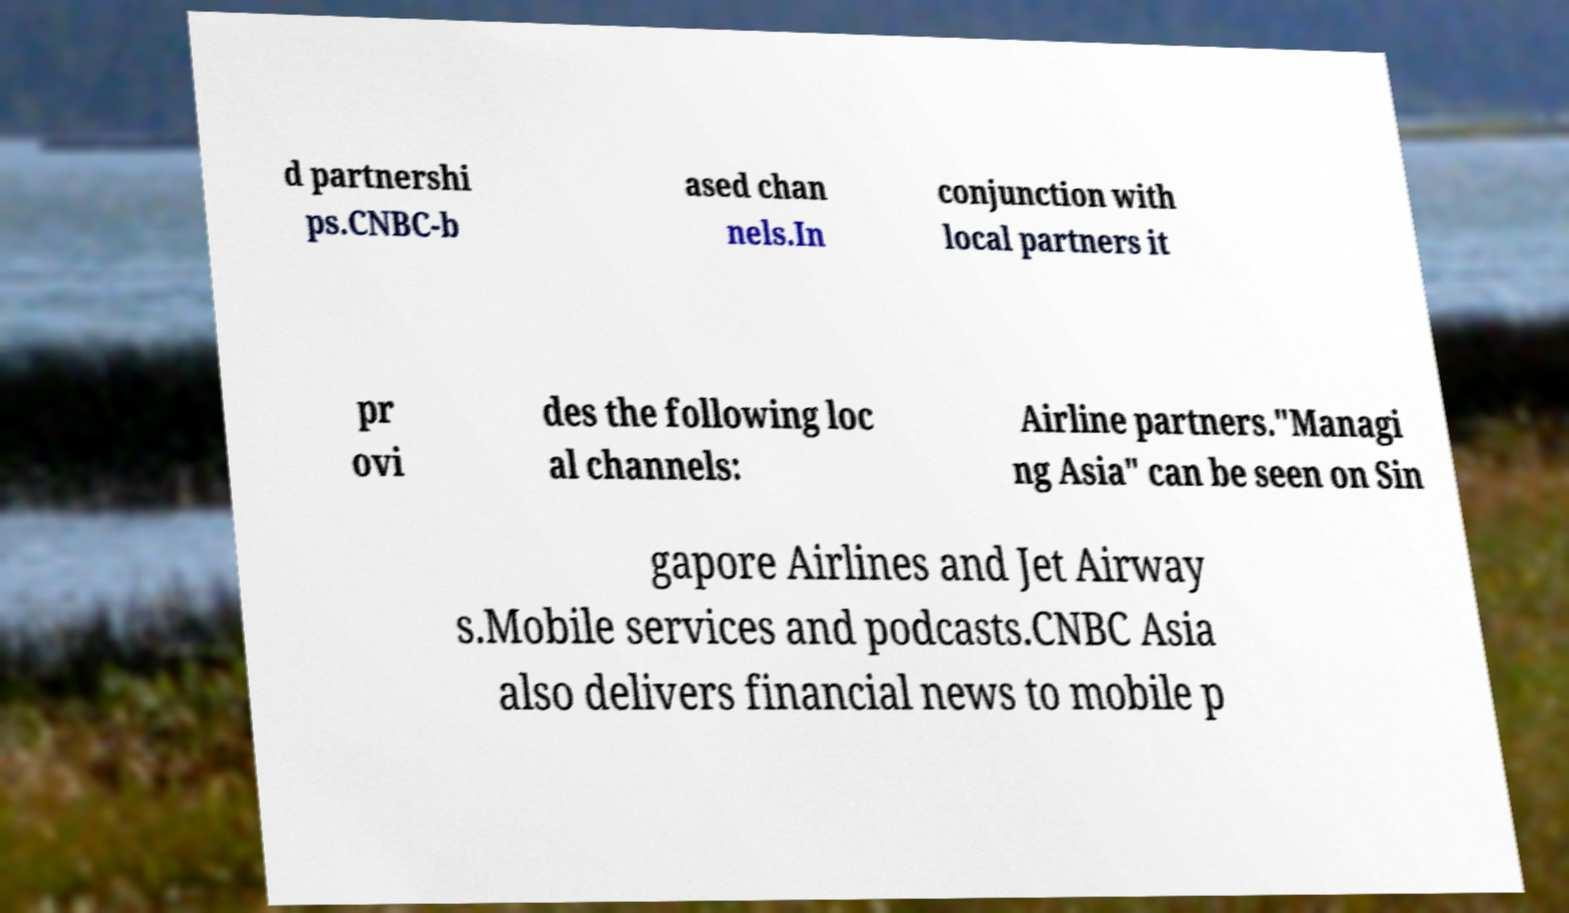Could you assist in decoding the text presented in this image and type it out clearly? d partnershi ps.CNBC-b ased chan nels.In conjunction with local partners it pr ovi des the following loc al channels: Airline partners."Managi ng Asia" can be seen on Sin gapore Airlines and Jet Airway s.Mobile services and podcasts.CNBC Asia also delivers financial news to mobile p 